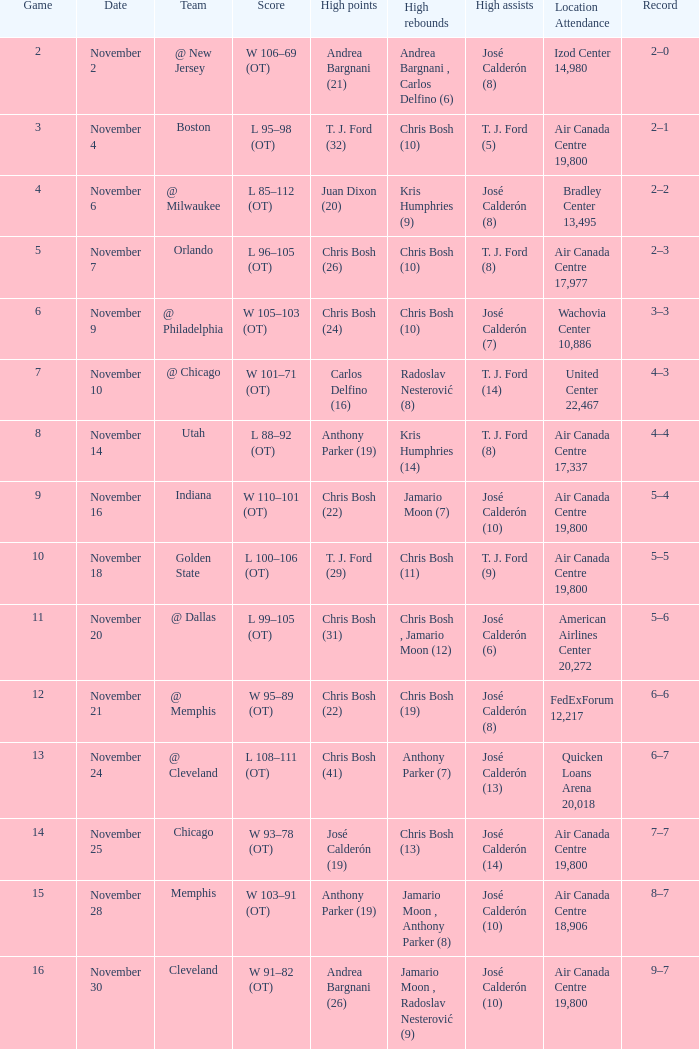Who was the highest scorer during the game where chris bosh recorded 13 high rebounds? José Calderón (19). Parse the full table. {'header': ['Game', 'Date', 'Team', 'Score', 'High points', 'High rebounds', 'High assists', 'Location Attendance', 'Record'], 'rows': [['2', 'November 2', '@ New Jersey', 'W 106–69 (OT)', 'Andrea Bargnani (21)', 'Andrea Bargnani , Carlos Delfino (6)', 'José Calderón (8)', 'Izod Center 14,980', '2–0'], ['3', 'November 4', 'Boston', 'L 95–98 (OT)', 'T. J. Ford (32)', 'Chris Bosh (10)', 'T. J. Ford (5)', 'Air Canada Centre 19,800', '2–1'], ['4', 'November 6', '@ Milwaukee', 'L 85–112 (OT)', 'Juan Dixon (20)', 'Kris Humphries (9)', 'José Calderón (8)', 'Bradley Center 13,495', '2–2'], ['5', 'November 7', 'Orlando', 'L 96–105 (OT)', 'Chris Bosh (26)', 'Chris Bosh (10)', 'T. J. Ford (8)', 'Air Canada Centre 17,977', '2–3'], ['6', 'November 9', '@ Philadelphia', 'W 105–103 (OT)', 'Chris Bosh (24)', 'Chris Bosh (10)', 'José Calderón (7)', 'Wachovia Center 10,886', '3–3'], ['7', 'November 10', '@ Chicago', 'W 101–71 (OT)', 'Carlos Delfino (16)', 'Radoslav Nesterović (8)', 'T. J. Ford (14)', 'United Center 22,467', '4–3'], ['8', 'November 14', 'Utah', 'L 88–92 (OT)', 'Anthony Parker (19)', 'Kris Humphries (14)', 'T. J. Ford (8)', 'Air Canada Centre 17,337', '4–4'], ['9', 'November 16', 'Indiana', 'W 110–101 (OT)', 'Chris Bosh (22)', 'Jamario Moon (7)', 'José Calderón (10)', 'Air Canada Centre 19,800', '5–4'], ['10', 'November 18', 'Golden State', 'L 100–106 (OT)', 'T. J. Ford (29)', 'Chris Bosh (11)', 'T. J. Ford (9)', 'Air Canada Centre 19,800', '5–5'], ['11', 'November 20', '@ Dallas', 'L 99–105 (OT)', 'Chris Bosh (31)', 'Chris Bosh , Jamario Moon (12)', 'José Calderón (6)', 'American Airlines Center 20,272', '5–6'], ['12', 'November 21', '@ Memphis', 'W 95–89 (OT)', 'Chris Bosh (22)', 'Chris Bosh (19)', 'José Calderón (8)', 'FedExForum 12,217', '6–6'], ['13', 'November 24', '@ Cleveland', 'L 108–111 (OT)', 'Chris Bosh (41)', 'Anthony Parker (7)', 'José Calderón (13)', 'Quicken Loans Arena 20,018', '6–7'], ['14', 'November 25', 'Chicago', 'W 93–78 (OT)', 'José Calderón (19)', 'Chris Bosh (13)', 'José Calderón (14)', 'Air Canada Centre 19,800', '7–7'], ['15', 'November 28', 'Memphis', 'W 103–91 (OT)', 'Anthony Parker (19)', 'Jamario Moon , Anthony Parker (8)', 'José Calderón (10)', 'Air Canada Centre 18,906', '8–7'], ['16', 'November 30', 'Cleveland', 'W 91–82 (OT)', 'Andrea Bargnani (26)', 'Jamario Moon , Radoslav Nesterović (9)', 'José Calderón (10)', 'Air Canada Centre 19,800', '9–7']]} 